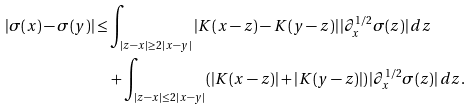<formula> <loc_0><loc_0><loc_500><loc_500>| \sigma ( x ) - \sigma ( y ) | \leq & \int _ { | z - x | \geq 2 \, | x - y | } | K ( x - z ) - K ( y - z ) | \, | \partial ^ { 1 / 2 } _ { x } \sigma ( z ) | \, d z \\ & + \int _ { | z - x | \leq 2 \, | x - y | } ( | K ( x - z ) | + | K ( y - z ) | ) \, | \partial ^ { 1 / 2 } _ { x } \sigma ( z ) | \, d z .</formula> 